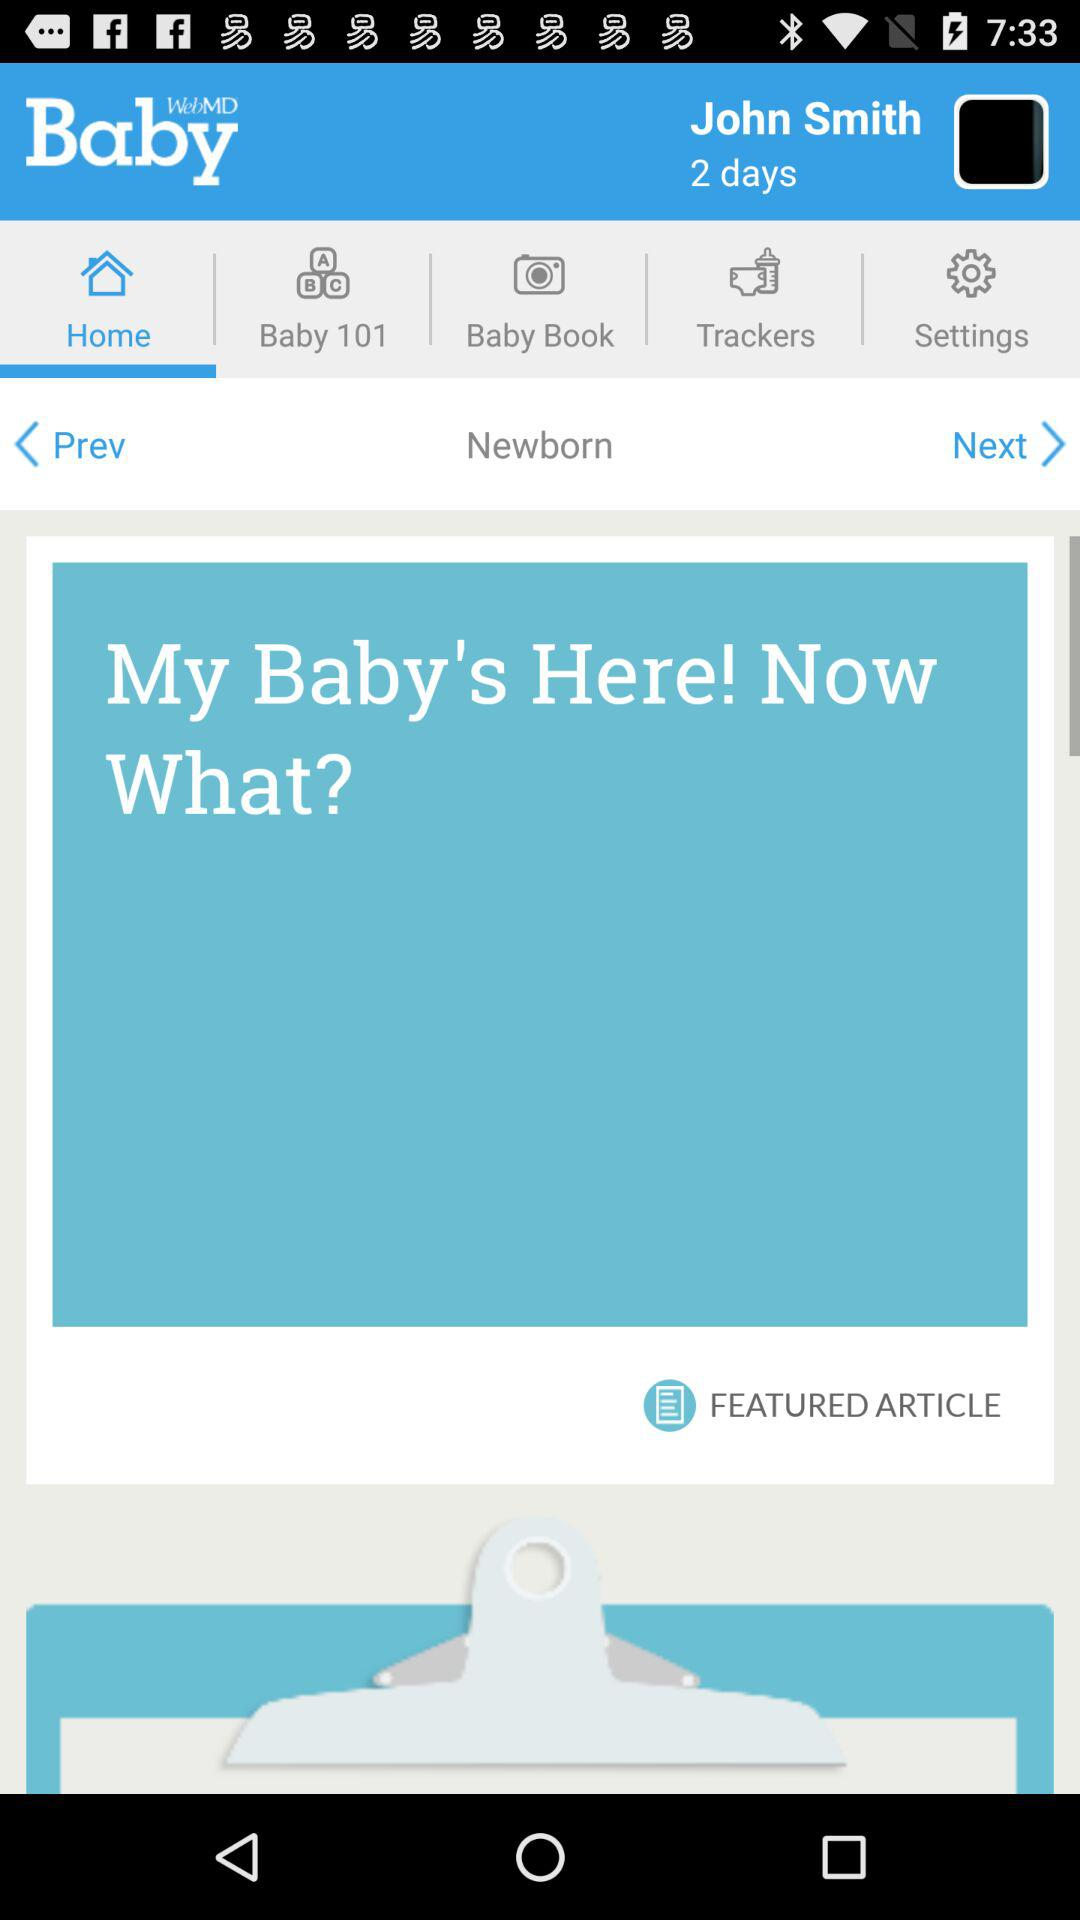What is the app name? The app name is "WebMD Baby". 